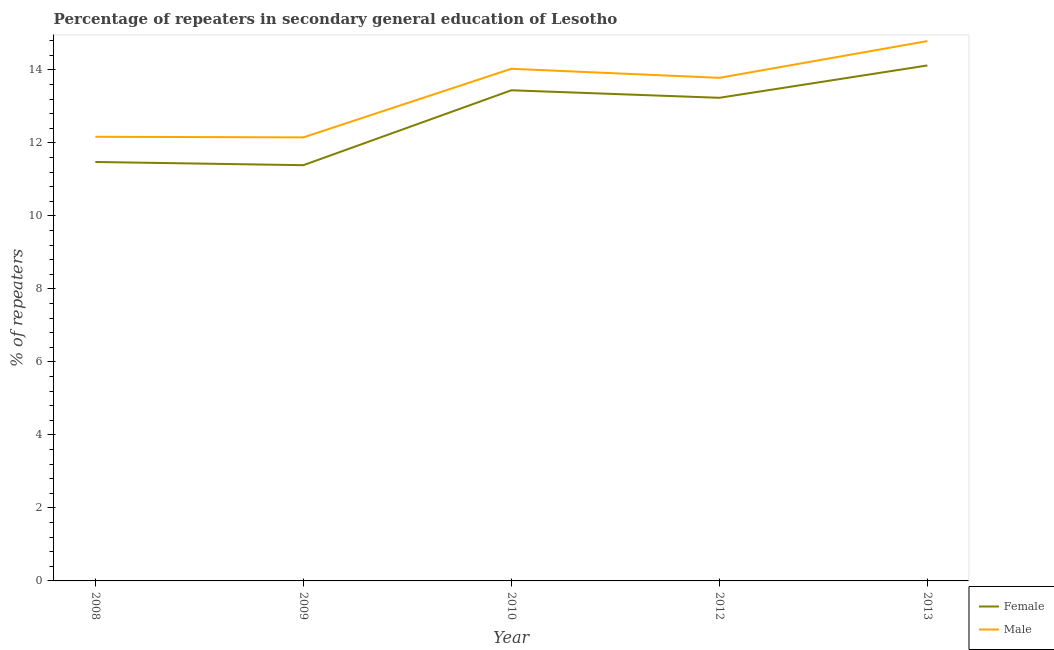How many different coloured lines are there?
Make the answer very short. 2. What is the percentage of male repeaters in 2010?
Your response must be concise. 14.03. Across all years, what is the maximum percentage of female repeaters?
Your response must be concise. 14.12. Across all years, what is the minimum percentage of male repeaters?
Your answer should be very brief. 12.15. In which year was the percentage of male repeaters maximum?
Your answer should be very brief. 2013. What is the total percentage of male repeaters in the graph?
Provide a short and direct response. 66.92. What is the difference between the percentage of female repeaters in 2008 and that in 2012?
Your answer should be compact. -1.76. What is the difference between the percentage of female repeaters in 2009 and the percentage of male repeaters in 2010?
Provide a short and direct response. -2.64. What is the average percentage of female repeaters per year?
Make the answer very short. 12.73. In the year 2008, what is the difference between the percentage of female repeaters and percentage of male repeaters?
Provide a short and direct response. -0.69. In how many years, is the percentage of female repeaters greater than 6.4 %?
Your answer should be compact. 5. What is the ratio of the percentage of female repeaters in 2010 to that in 2012?
Offer a terse response. 1.02. Is the percentage of male repeaters in 2009 less than that in 2012?
Ensure brevity in your answer.  Yes. What is the difference between the highest and the second highest percentage of male repeaters?
Provide a short and direct response. 0.76. What is the difference between the highest and the lowest percentage of female repeaters?
Make the answer very short. 2.73. Does the percentage of male repeaters monotonically increase over the years?
Ensure brevity in your answer.  No. Is the percentage of male repeaters strictly greater than the percentage of female repeaters over the years?
Keep it short and to the point. Yes. Is the percentage of female repeaters strictly less than the percentage of male repeaters over the years?
Keep it short and to the point. Yes. How many lines are there?
Give a very brief answer. 2. What is the difference between two consecutive major ticks on the Y-axis?
Provide a succinct answer. 2. Does the graph contain grids?
Offer a terse response. No. Where does the legend appear in the graph?
Ensure brevity in your answer.  Bottom right. How many legend labels are there?
Offer a terse response. 2. How are the legend labels stacked?
Provide a short and direct response. Vertical. What is the title of the graph?
Ensure brevity in your answer.  Percentage of repeaters in secondary general education of Lesotho. Does "Nitrous oxide" appear as one of the legend labels in the graph?
Keep it short and to the point. No. What is the label or title of the Y-axis?
Your response must be concise. % of repeaters. What is the % of repeaters in Female in 2008?
Make the answer very short. 11.48. What is the % of repeaters of Male in 2008?
Give a very brief answer. 12.17. What is the % of repeaters of Female in 2009?
Keep it short and to the point. 11.39. What is the % of repeaters in Male in 2009?
Your answer should be very brief. 12.15. What is the % of repeaters in Female in 2010?
Offer a very short reply. 13.44. What is the % of repeaters of Male in 2010?
Offer a terse response. 14.03. What is the % of repeaters of Female in 2012?
Provide a short and direct response. 13.23. What is the % of repeaters of Male in 2012?
Make the answer very short. 13.78. What is the % of repeaters in Female in 2013?
Your answer should be very brief. 14.12. What is the % of repeaters of Male in 2013?
Give a very brief answer. 14.79. Across all years, what is the maximum % of repeaters of Female?
Ensure brevity in your answer.  14.12. Across all years, what is the maximum % of repeaters of Male?
Your answer should be compact. 14.79. Across all years, what is the minimum % of repeaters in Female?
Your response must be concise. 11.39. Across all years, what is the minimum % of repeaters of Male?
Offer a very short reply. 12.15. What is the total % of repeaters in Female in the graph?
Offer a very short reply. 63.66. What is the total % of repeaters in Male in the graph?
Ensure brevity in your answer.  66.92. What is the difference between the % of repeaters in Female in 2008 and that in 2009?
Give a very brief answer. 0.09. What is the difference between the % of repeaters of Male in 2008 and that in 2009?
Offer a very short reply. 0.02. What is the difference between the % of repeaters in Female in 2008 and that in 2010?
Make the answer very short. -1.96. What is the difference between the % of repeaters of Male in 2008 and that in 2010?
Provide a succinct answer. -1.86. What is the difference between the % of repeaters of Female in 2008 and that in 2012?
Make the answer very short. -1.76. What is the difference between the % of repeaters of Male in 2008 and that in 2012?
Offer a very short reply. -1.61. What is the difference between the % of repeaters in Female in 2008 and that in 2013?
Provide a short and direct response. -2.64. What is the difference between the % of repeaters in Male in 2008 and that in 2013?
Offer a very short reply. -2.62. What is the difference between the % of repeaters of Female in 2009 and that in 2010?
Offer a terse response. -2.05. What is the difference between the % of repeaters of Male in 2009 and that in 2010?
Ensure brevity in your answer.  -1.88. What is the difference between the % of repeaters of Female in 2009 and that in 2012?
Offer a very short reply. -1.85. What is the difference between the % of repeaters in Male in 2009 and that in 2012?
Provide a succinct answer. -1.63. What is the difference between the % of repeaters of Female in 2009 and that in 2013?
Ensure brevity in your answer.  -2.73. What is the difference between the % of repeaters in Male in 2009 and that in 2013?
Your response must be concise. -2.64. What is the difference between the % of repeaters of Female in 2010 and that in 2012?
Your answer should be very brief. 0.21. What is the difference between the % of repeaters of Male in 2010 and that in 2012?
Give a very brief answer. 0.25. What is the difference between the % of repeaters of Female in 2010 and that in 2013?
Provide a succinct answer. -0.68. What is the difference between the % of repeaters of Male in 2010 and that in 2013?
Your answer should be very brief. -0.76. What is the difference between the % of repeaters in Female in 2012 and that in 2013?
Offer a terse response. -0.89. What is the difference between the % of repeaters in Male in 2012 and that in 2013?
Offer a terse response. -1.01. What is the difference between the % of repeaters in Female in 2008 and the % of repeaters in Male in 2009?
Make the answer very short. -0.67. What is the difference between the % of repeaters in Female in 2008 and the % of repeaters in Male in 2010?
Provide a short and direct response. -2.55. What is the difference between the % of repeaters in Female in 2008 and the % of repeaters in Male in 2012?
Offer a terse response. -2.3. What is the difference between the % of repeaters in Female in 2008 and the % of repeaters in Male in 2013?
Ensure brevity in your answer.  -3.31. What is the difference between the % of repeaters of Female in 2009 and the % of repeaters of Male in 2010?
Provide a short and direct response. -2.64. What is the difference between the % of repeaters in Female in 2009 and the % of repeaters in Male in 2012?
Ensure brevity in your answer.  -2.39. What is the difference between the % of repeaters of Female in 2009 and the % of repeaters of Male in 2013?
Your response must be concise. -3.4. What is the difference between the % of repeaters of Female in 2010 and the % of repeaters of Male in 2012?
Provide a short and direct response. -0.34. What is the difference between the % of repeaters in Female in 2010 and the % of repeaters in Male in 2013?
Provide a short and direct response. -1.35. What is the difference between the % of repeaters of Female in 2012 and the % of repeaters of Male in 2013?
Provide a short and direct response. -1.55. What is the average % of repeaters in Female per year?
Offer a terse response. 12.73. What is the average % of repeaters in Male per year?
Your response must be concise. 13.38. In the year 2008, what is the difference between the % of repeaters in Female and % of repeaters in Male?
Make the answer very short. -0.69. In the year 2009, what is the difference between the % of repeaters of Female and % of repeaters of Male?
Provide a succinct answer. -0.76. In the year 2010, what is the difference between the % of repeaters of Female and % of repeaters of Male?
Offer a very short reply. -0.59. In the year 2012, what is the difference between the % of repeaters in Female and % of repeaters in Male?
Offer a very short reply. -0.55. In the year 2013, what is the difference between the % of repeaters in Female and % of repeaters in Male?
Offer a terse response. -0.67. What is the ratio of the % of repeaters of Female in 2008 to that in 2009?
Make the answer very short. 1.01. What is the ratio of the % of repeaters in Male in 2008 to that in 2009?
Provide a succinct answer. 1. What is the ratio of the % of repeaters of Female in 2008 to that in 2010?
Keep it short and to the point. 0.85. What is the ratio of the % of repeaters of Male in 2008 to that in 2010?
Offer a terse response. 0.87. What is the ratio of the % of repeaters in Female in 2008 to that in 2012?
Keep it short and to the point. 0.87. What is the ratio of the % of repeaters in Male in 2008 to that in 2012?
Provide a short and direct response. 0.88. What is the ratio of the % of repeaters of Female in 2008 to that in 2013?
Offer a terse response. 0.81. What is the ratio of the % of repeaters in Male in 2008 to that in 2013?
Offer a very short reply. 0.82. What is the ratio of the % of repeaters of Female in 2009 to that in 2010?
Offer a terse response. 0.85. What is the ratio of the % of repeaters in Male in 2009 to that in 2010?
Provide a short and direct response. 0.87. What is the ratio of the % of repeaters of Female in 2009 to that in 2012?
Your answer should be compact. 0.86. What is the ratio of the % of repeaters in Male in 2009 to that in 2012?
Offer a very short reply. 0.88. What is the ratio of the % of repeaters of Female in 2009 to that in 2013?
Offer a terse response. 0.81. What is the ratio of the % of repeaters of Male in 2009 to that in 2013?
Provide a succinct answer. 0.82. What is the ratio of the % of repeaters of Female in 2010 to that in 2012?
Give a very brief answer. 1.02. What is the ratio of the % of repeaters in Male in 2010 to that in 2012?
Ensure brevity in your answer.  1.02. What is the ratio of the % of repeaters in Female in 2010 to that in 2013?
Provide a short and direct response. 0.95. What is the ratio of the % of repeaters in Male in 2010 to that in 2013?
Make the answer very short. 0.95. What is the ratio of the % of repeaters in Female in 2012 to that in 2013?
Offer a terse response. 0.94. What is the ratio of the % of repeaters of Male in 2012 to that in 2013?
Provide a succinct answer. 0.93. What is the difference between the highest and the second highest % of repeaters of Female?
Offer a terse response. 0.68. What is the difference between the highest and the second highest % of repeaters of Male?
Give a very brief answer. 0.76. What is the difference between the highest and the lowest % of repeaters in Female?
Your response must be concise. 2.73. What is the difference between the highest and the lowest % of repeaters in Male?
Offer a very short reply. 2.64. 